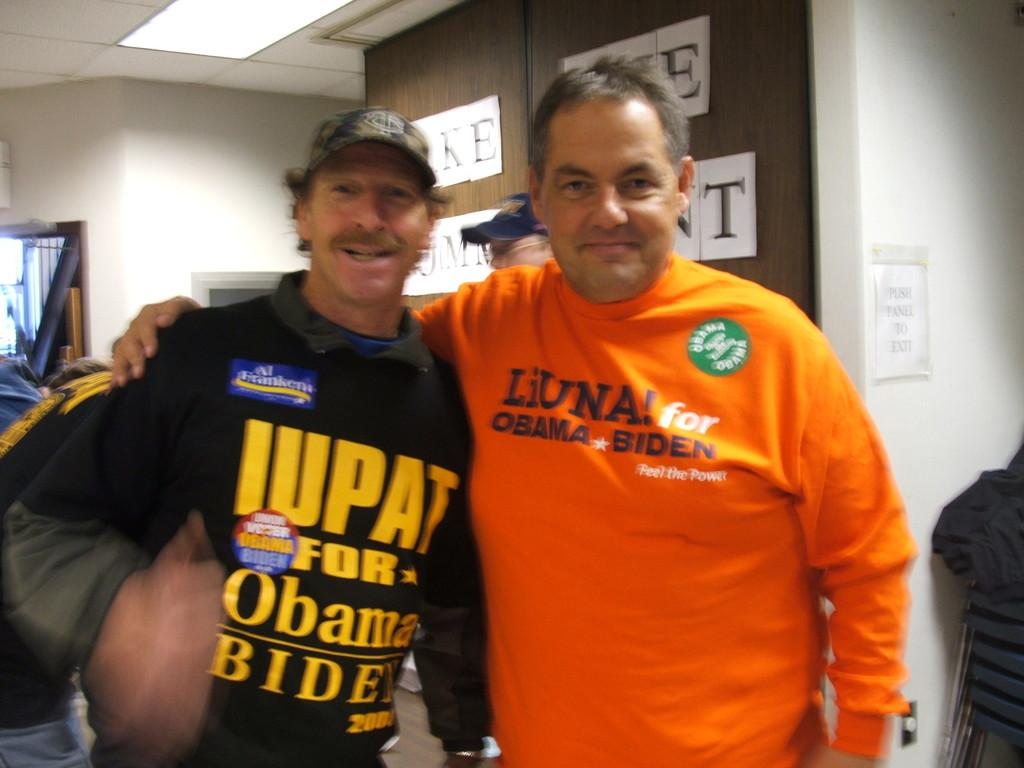<image>
Create a compact narrative representing the image presented. Two men at a political event wearing Obama/Biden shirts 